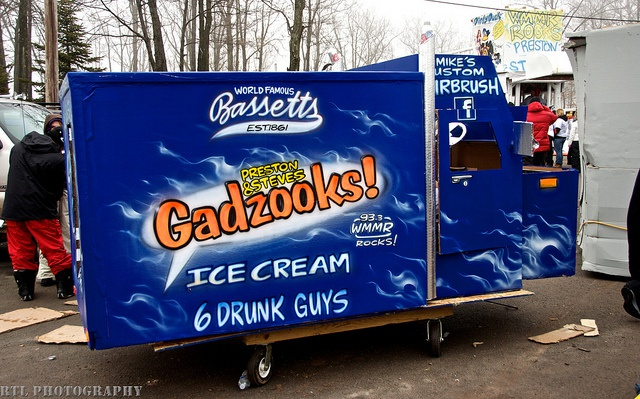Describe the objects in this image and their specific colors. I can see truck in gray, navy, black, darkblue, and lightgray tones, people in gray, black, maroon, and red tones, car in gray, lightgray, darkgray, and lightblue tones, people in gray, black, brown, and maroon tones, and people in gray, black, white, and darkgray tones in this image. 